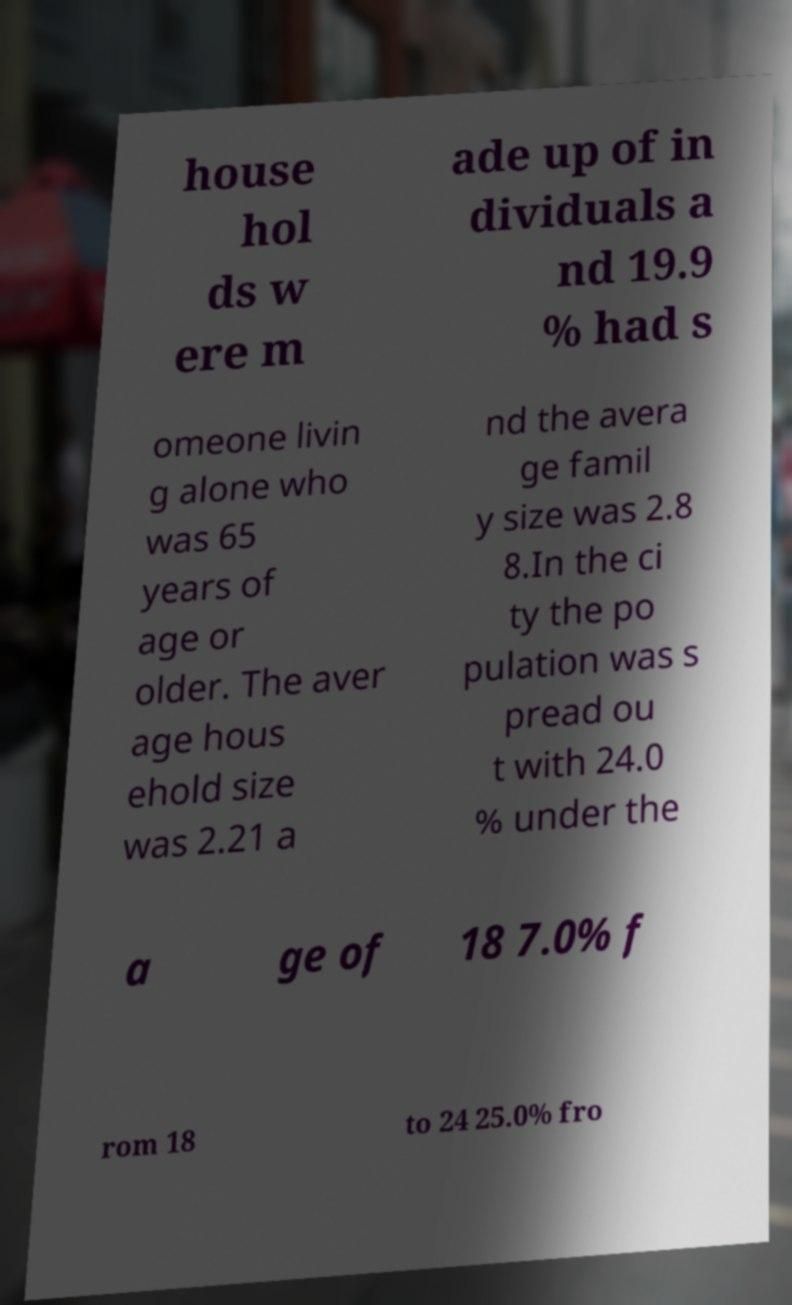Can you read and provide the text displayed in the image?This photo seems to have some interesting text. Can you extract and type it out for me? house hol ds w ere m ade up of in dividuals a nd 19.9 % had s omeone livin g alone who was 65 years of age or older. The aver age hous ehold size was 2.21 a nd the avera ge famil y size was 2.8 8.In the ci ty the po pulation was s pread ou t with 24.0 % under the a ge of 18 7.0% f rom 18 to 24 25.0% fro 